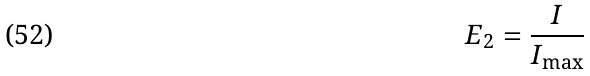Convert formula to latex. <formula><loc_0><loc_0><loc_500><loc_500>E _ { 2 } = \frac { I } { I _ { \max } }</formula> 